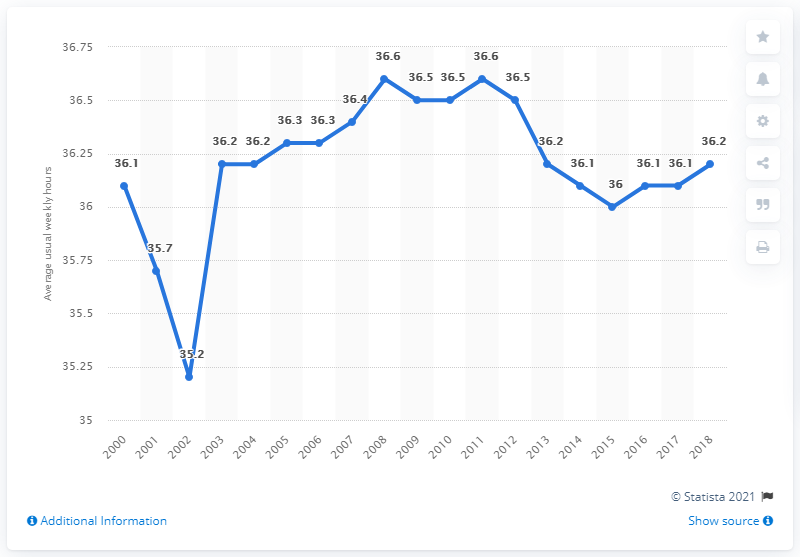Specify some key components in this picture. I have a value of 36.6% and I have a total of 2 years. In 2002, the year with the least value was Between 2008 and 2011, the weekly average for working hours was 36.6 hours. 